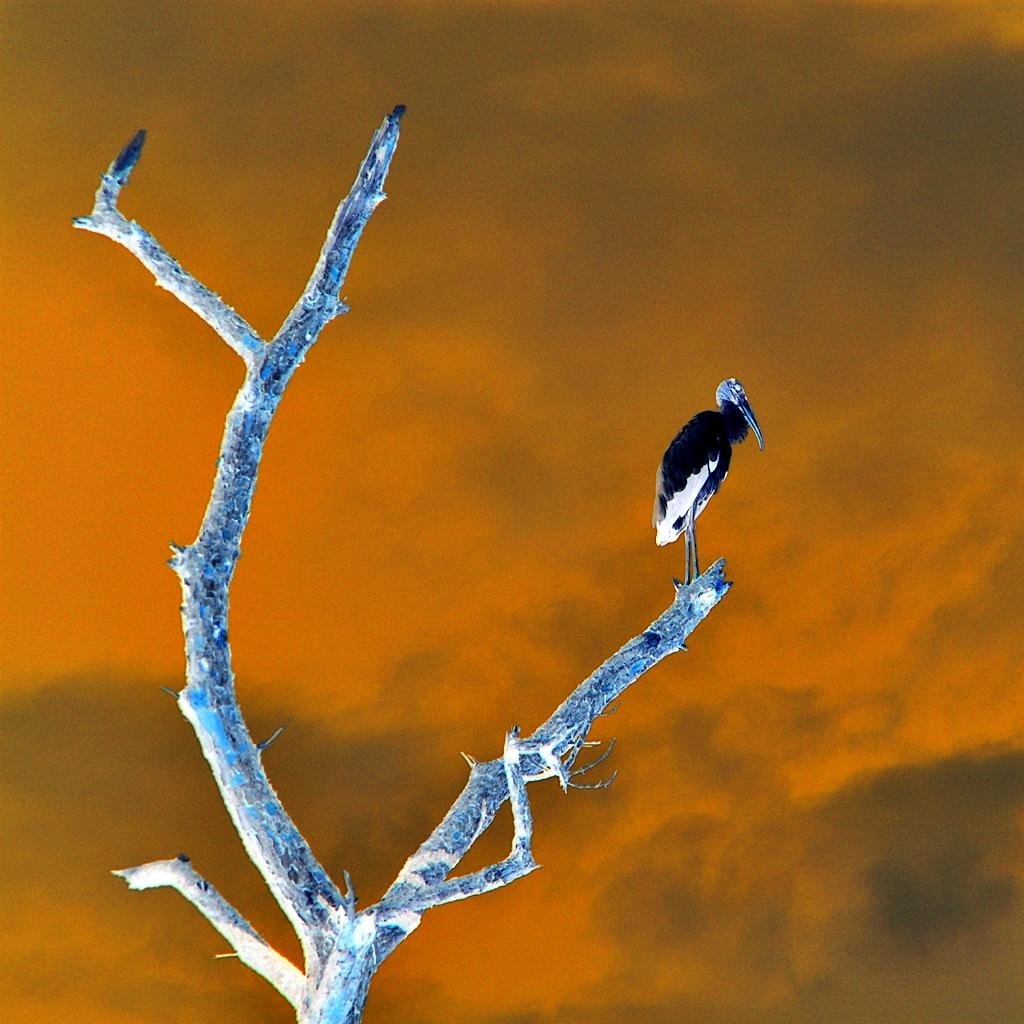What type of animal can be seen in the image? There is a bird in the image. Where is the bird located? The bird is on a branch. What part of the natural environment is visible in the image? The sky is visible in the image. What type of whistle is the bird using in the image? There is no whistle present in the image, and birds do not use whistles. 